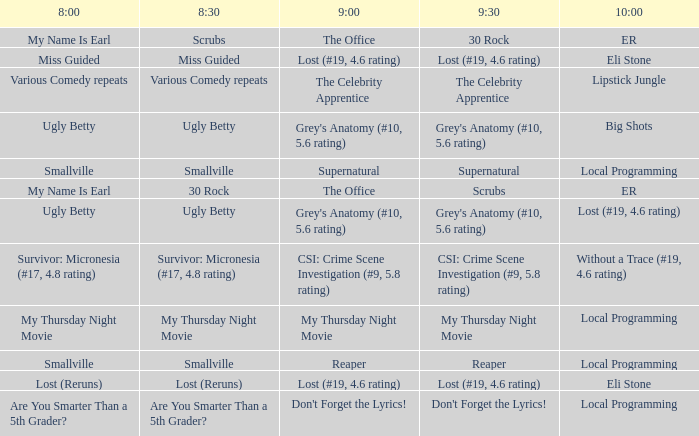What is at 9:00 when at 10:00 it is local programming and at 9:30 it is my thursday night movie? My Thursday Night Movie. 